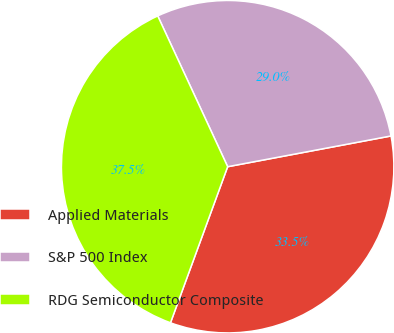Convert chart to OTSL. <chart><loc_0><loc_0><loc_500><loc_500><pie_chart><fcel>Applied Materials<fcel>S&P 500 Index<fcel>RDG Semiconductor Composite<nl><fcel>33.55%<fcel>28.95%<fcel>37.5%<nl></chart> 